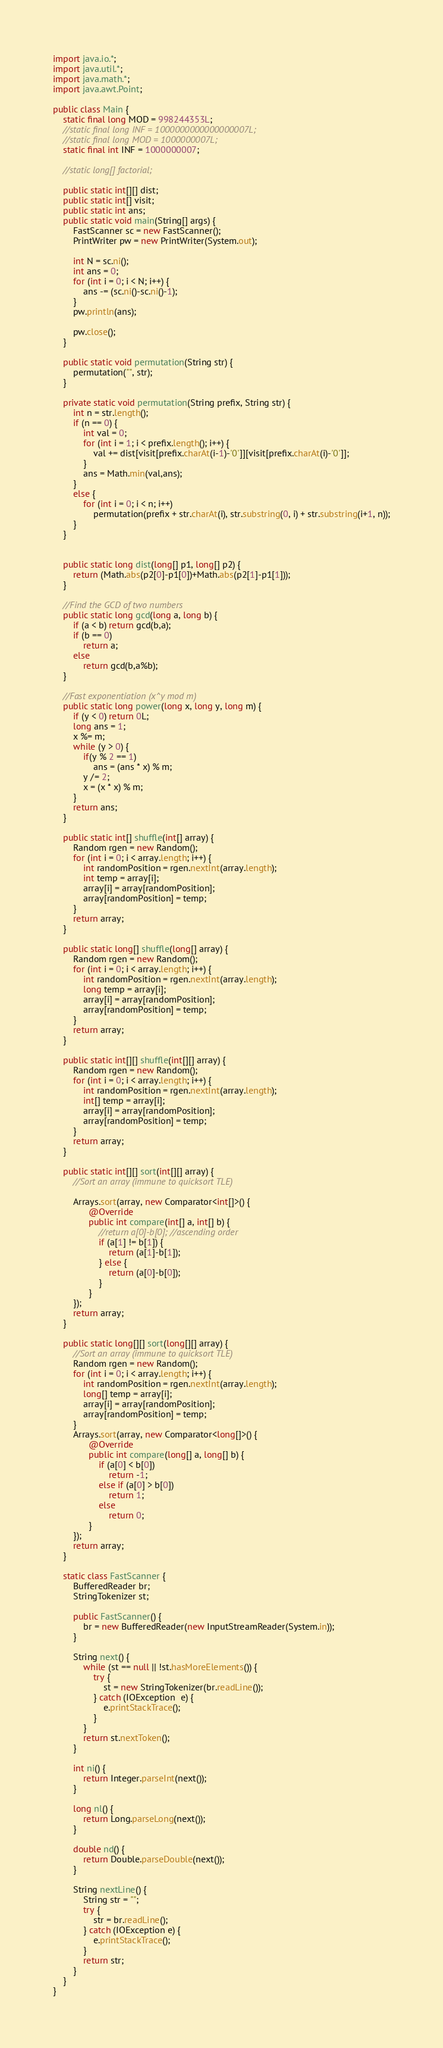Convert code to text. <code><loc_0><loc_0><loc_500><loc_500><_Java_>import java.io.*;
import java.util.*;
import java.math.*;
import java.awt.Point;
 
public class Main {
	static final long MOD = 998244353L;
	//static final long INF = 1000000000000000007L;
	//static final long MOD = 1000000007L;
	static final int INF = 1000000007;
	
	//static long[] factorial;
	
	public static int[][] dist;
	public static int[] visit;
	public static int ans;
	public static void main(String[] args) {
		FastScanner sc = new FastScanner();
		PrintWriter pw = new PrintWriter(System.out);
		
		int N = sc.ni();
		int ans = 0;
		for (int i = 0; i < N; i++) {
			ans -= (sc.ni()-sc.ni()-1);
		}
		pw.println(ans);
		
		pw.close();
	}
	
	public static void permutation(String str) { 
	    permutation("", str); 
	}

	private static void permutation(String prefix, String str) {
	    int n = str.length();
	    if (n == 0) {
	    	int val = 0;
	    	for (int i = 1; i < prefix.length(); i++) {
	    		val += dist[visit[prefix.charAt(i-1)-'0']][visit[prefix.charAt(i)-'0']];
	    	}
	    	ans = Math.min(val,ans);
	    }
	    else {
	        for (int i = 0; i < n; i++)
	            permutation(prefix + str.charAt(i), str.substring(0, i) + str.substring(i+1, n));
	    }
	}
	
 
	public static long dist(long[] p1, long[] p2) {
		return (Math.abs(p2[0]-p1[0])+Math.abs(p2[1]-p1[1]));
	}
	
	//Find the GCD of two numbers
	public static long gcd(long a, long b) {
		if (a < b) return gcd(b,a);
		if (b == 0)
			return a;
		else
			return gcd(b,a%b);
	}
	
	//Fast exponentiation (x^y mod m)
	public static long power(long x, long y, long m) { 
		if (y < 0) return 0L;
		long ans = 1;
		x %= m;
		while (y > 0) { 
			if(y % 2 == 1) 
				ans = (ans * x) % m; 
			y /= 2;  
			x = (x * x) % m;
		} 
		return ans; 
	}
	
	public static int[] shuffle(int[] array) {
		Random rgen = new Random();
		for (int i = 0; i < array.length; i++) {
		    int randomPosition = rgen.nextInt(array.length);
		    int temp = array[i];
		    array[i] = array[randomPosition];
		    array[randomPosition] = temp;
		}
		return array;
	}
	
	public static long[] shuffle(long[] array) {
		Random rgen = new Random();
		for (int i = 0; i < array.length; i++) {
		    int randomPosition = rgen.nextInt(array.length);
		    long temp = array[i];
		    array[i] = array[randomPosition];
		    array[randomPosition] = temp;
		}
		return array;
	}
	
	public static int[][] shuffle(int[][] array) {
		Random rgen = new Random();
		for (int i = 0; i < array.length; i++) {
		    int randomPosition = rgen.nextInt(array.length);
		    int[] temp = array[i];
		    array[i] = array[randomPosition];
		    array[randomPosition] = temp;
		}
		return array;
	}
	
    public static int[][] sort(int[][] array) {
    	//Sort an array (immune to quicksort TLE)
 
		Arrays.sort(array, new Comparator<int[]>() {
			  @Override
        	  public int compare(int[] a, int[] b) {
				  //return a[0]-b[0]; //ascending order
				  if (a[1] != b[1]) {
					  return (a[1]-b[1]);
				  } else {
					  return (a[0]-b[0]);
				  }
	          }
		});
		return array;
	}
    
    public static long[][] sort(long[][] array) {
    	//Sort an array (immune to quicksort TLE)
		Random rgen = new Random();
		for (int i = 0; i < array.length; i++) {
		    int randomPosition = rgen.nextInt(array.length);
		    long[] temp = array[i];
		    array[i] = array[randomPosition];
		    array[randomPosition] = temp;
		}
		Arrays.sort(array, new Comparator<long[]>() {
			  @Override
        	  public int compare(long[] a, long[] b) {
				  if (a[0] < b[0])
					  return -1;
				  else if (a[0] > b[0])
					  return 1;
				  else
					  return 0;
	          }
		});
		return array;
	}
    
    static class FastScanner { 
        BufferedReader br; 
        StringTokenizer st; 
  
        public FastScanner() { 
            br = new BufferedReader(new InputStreamReader(System.in)); 
        } 
  
        String next() { 
            while (st == null || !st.hasMoreElements()) { 
                try { 
                    st = new StringTokenizer(br.readLine());
                } catch (IOException  e) { 
                    e.printStackTrace(); 
                } 
            } 
            return st.nextToken(); 
        }
        
        int ni() { 
            return Integer.parseInt(next()); 
        }
  
        long nl() { 
            return Long.parseLong(next()); 
        } 
  
        double nd() { 
            return Double.parseDouble(next()); 
        } 
  
        String nextLine() {
            String str = ""; 
            try { 
                str = br.readLine(); 
            } catch (IOException e) {
                e.printStackTrace(); 
            } 
            return str;
        }
    }
}</code> 